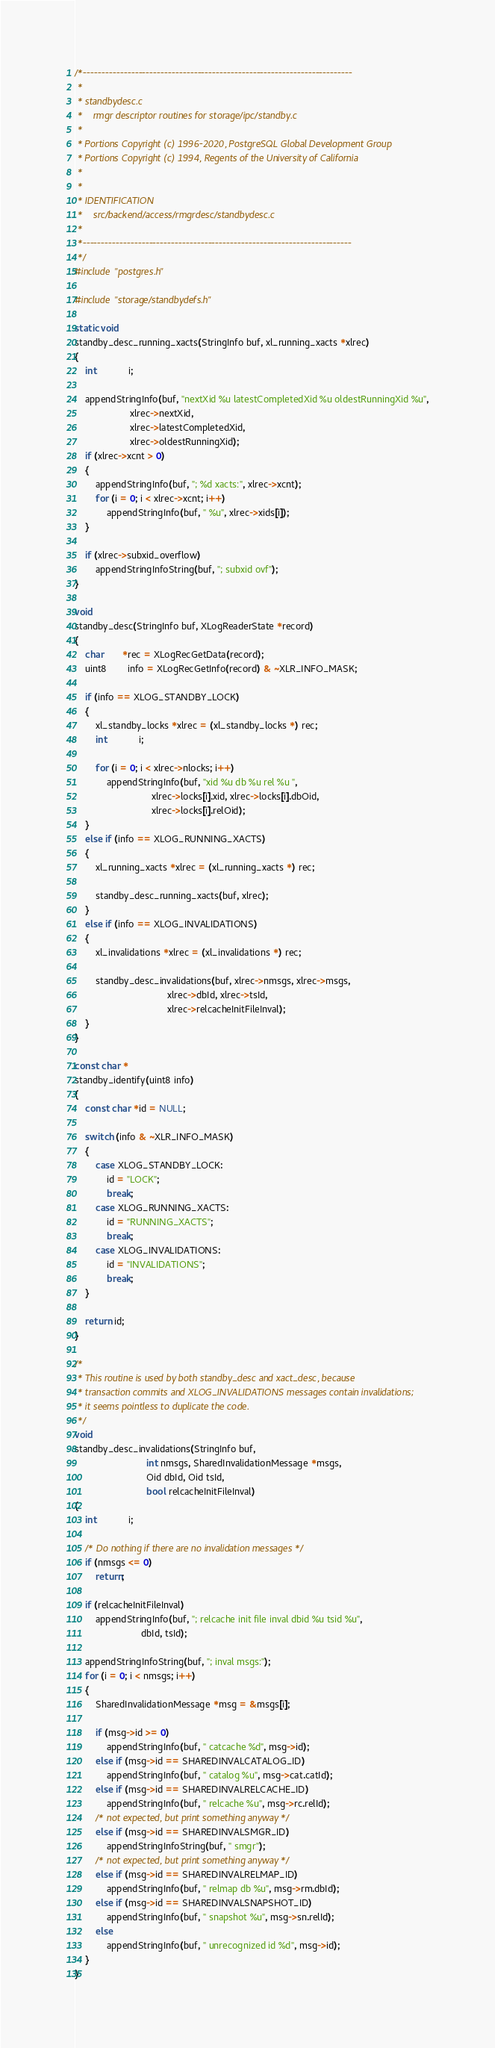<code> <loc_0><loc_0><loc_500><loc_500><_C_>/*-------------------------------------------------------------------------
 *
 * standbydesc.c
 *	  rmgr descriptor routines for storage/ipc/standby.c
 *
 * Portions Copyright (c) 1996-2020, PostgreSQL Global Development Group
 * Portions Copyright (c) 1994, Regents of the University of California
 *
 *
 * IDENTIFICATION
 *	  src/backend/access/rmgrdesc/standbydesc.c
 *
 *-------------------------------------------------------------------------
 */
#include "postgres.h"

#include "storage/standbydefs.h"

static void
standby_desc_running_xacts(StringInfo buf, xl_running_xacts *xlrec)
{
	int			i;

	appendStringInfo(buf, "nextXid %u latestCompletedXid %u oldestRunningXid %u",
					 xlrec->nextXid,
					 xlrec->latestCompletedXid,
					 xlrec->oldestRunningXid);
	if (xlrec->xcnt > 0)
	{
		appendStringInfo(buf, "; %d xacts:", xlrec->xcnt);
		for (i = 0; i < xlrec->xcnt; i++)
			appendStringInfo(buf, " %u", xlrec->xids[i]);
	}

	if (xlrec->subxid_overflow)
		appendStringInfoString(buf, "; subxid ovf");
}

void
standby_desc(StringInfo buf, XLogReaderState *record)
{
	char	   *rec = XLogRecGetData(record);
	uint8		info = XLogRecGetInfo(record) & ~XLR_INFO_MASK;

	if (info == XLOG_STANDBY_LOCK)
	{
		xl_standby_locks *xlrec = (xl_standby_locks *) rec;
		int			i;

		for (i = 0; i < xlrec->nlocks; i++)
			appendStringInfo(buf, "xid %u db %u rel %u ",
							 xlrec->locks[i].xid, xlrec->locks[i].dbOid,
							 xlrec->locks[i].relOid);
	}
	else if (info == XLOG_RUNNING_XACTS)
	{
		xl_running_xacts *xlrec = (xl_running_xacts *) rec;

		standby_desc_running_xacts(buf, xlrec);
	}
	else if (info == XLOG_INVALIDATIONS)
	{
		xl_invalidations *xlrec = (xl_invalidations *) rec;

		standby_desc_invalidations(buf, xlrec->nmsgs, xlrec->msgs,
								   xlrec->dbId, xlrec->tsId,
								   xlrec->relcacheInitFileInval);
	}
}

const char *
standby_identify(uint8 info)
{
	const char *id = NULL;

	switch (info & ~XLR_INFO_MASK)
	{
		case XLOG_STANDBY_LOCK:
			id = "LOCK";
			break;
		case XLOG_RUNNING_XACTS:
			id = "RUNNING_XACTS";
			break;
		case XLOG_INVALIDATIONS:
			id = "INVALIDATIONS";
			break;
	}

	return id;
}

/*
 * This routine is used by both standby_desc and xact_desc, because
 * transaction commits and XLOG_INVALIDATIONS messages contain invalidations;
 * it seems pointless to duplicate the code.
 */
void
standby_desc_invalidations(StringInfo buf,
						   int nmsgs, SharedInvalidationMessage *msgs,
						   Oid dbId, Oid tsId,
						   bool relcacheInitFileInval)
{
	int			i;

	/* Do nothing if there are no invalidation messages */
	if (nmsgs <= 0)
		return;

	if (relcacheInitFileInval)
		appendStringInfo(buf, "; relcache init file inval dbid %u tsid %u",
						 dbId, tsId);

	appendStringInfoString(buf, "; inval msgs:");
	for (i = 0; i < nmsgs; i++)
	{
		SharedInvalidationMessage *msg = &msgs[i];

		if (msg->id >= 0)
			appendStringInfo(buf, " catcache %d", msg->id);
		else if (msg->id == SHAREDINVALCATALOG_ID)
			appendStringInfo(buf, " catalog %u", msg->cat.catId);
		else if (msg->id == SHAREDINVALRELCACHE_ID)
			appendStringInfo(buf, " relcache %u", msg->rc.relId);
		/* not expected, but print something anyway */
		else if (msg->id == SHAREDINVALSMGR_ID)
			appendStringInfoString(buf, " smgr");
		/* not expected, but print something anyway */
		else if (msg->id == SHAREDINVALRELMAP_ID)
			appendStringInfo(buf, " relmap db %u", msg->rm.dbId);
		else if (msg->id == SHAREDINVALSNAPSHOT_ID)
			appendStringInfo(buf, " snapshot %u", msg->sn.relId);
		else
			appendStringInfo(buf, " unrecognized id %d", msg->id);
	}
}
</code> 